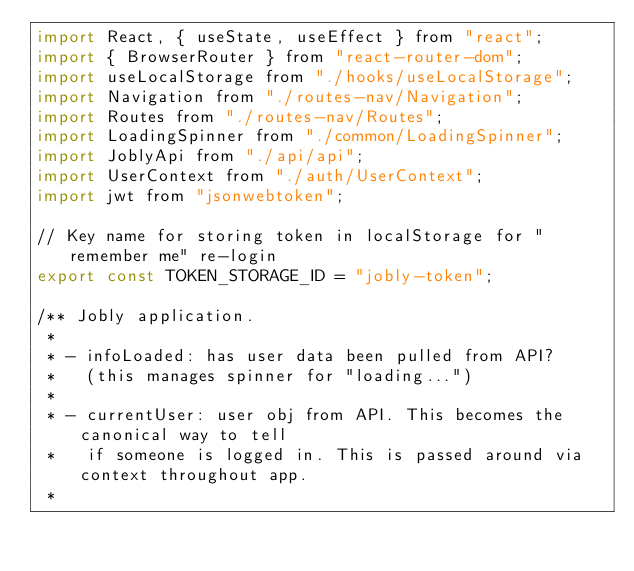Convert code to text. <code><loc_0><loc_0><loc_500><loc_500><_JavaScript_>import React, { useState, useEffect } from "react";
import { BrowserRouter } from "react-router-dom";
import useLocalStorage from "./hooks/useLocalStorage";
import Navigation from "./routes-nav/Navigation";
import Routes from "./routes-nav/Routes";
import LoadingSpinner from "./common/LoadingSpinner";
import JoblyApi from "./api/api";
import UserContext from "./auth/UserContext";
import jwt from "jsonwebtoken";

// Key name for storing token in localStorage for "remember me" re-login
export const TOKEN_STORAGE_ID = "jobly-token";

/** Jobly application.
 *
 * - infoLoaded: has user data been pulled from API?
 *   (this manages spinner for "loading...")
 *
 * - currentUser: user obj from API. This becomes the canonical way to tell
 *   if someone is logged in. This is passed around via context throughout app.
 *</code> 